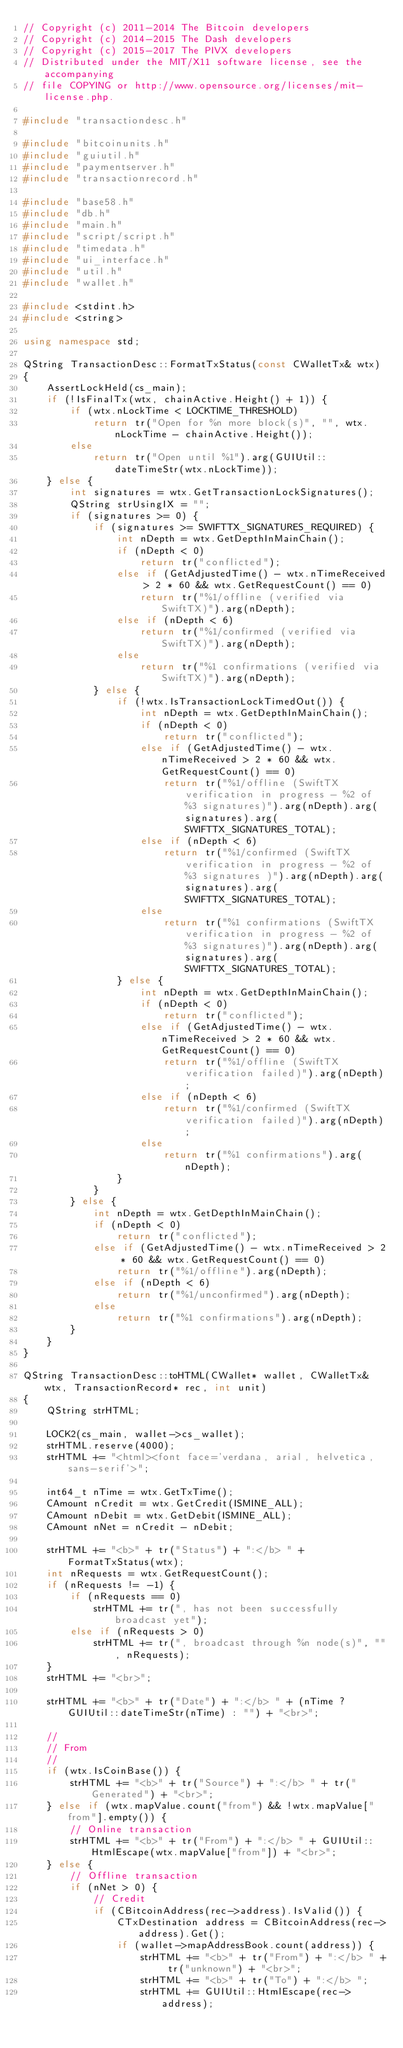Convert code to text. <code><loc_0><loc_0><loc_500><loc_500><_C++_>// Copyright (c) 2011-2014 The Bitcoin developers
// Copyright (c) 2014-2015 The Dash developers
// Copyright (c) 2015-2017 The PIVX developers
// Distributed under the MIT/X11 software license, see the accompanying
// file COPYING or http://www.opensource.org/licenses/mit-license.php.

#include "transactiondesc.h"

#include "bitcoinunits.h"
#include "guiutil.h"
#include "paymentserver.h"
#include "transactionrecord.h"

#include "base58.h"
#include "db.h"
#include "main.h"
#include "script/script.h"
#include "timedata.h"
#include "ui_interface.h"
#include "util.h"
#include "wallet.h"

#include <stdint.h>
#include <string>

using namespace std;

QString TransactionDesc::FormatTxStatus(const CWalletTx& wtx)
{
    AssertLockHeld(cs_main);
    if (!IsFinalTx(wtx, chainActive.Height() + 1)) {
        if (wtx.nLockTime < LOCKTIME_THRESHOLD)
            return tr("Open for %n more block(s)", "", wtx.nLockTime - chainActive.Height());
        else
            return tr("Open until %1").arg(GUIUtil::dateTimeStr(wtx.nLockTime));
    } else {
        int signatures = wtx.GetTransactionLockSignatures();
        QString strUsingIX = "";
        if (signatures >= 0) {
            if (signatures >= SWIFTTX_SIGNATURES_REQUIRED) {
                int nDepth = wtx.GetDepthInMainChain();
                if (nDepth < 0)
                    return tr("conflicted");
                else if (GetAdjustedTime() - wtx.nTimeReceived > 2 * 60 && wtx.GetRequestCount() == 0)
                    return tr("%1/offline (verified via SwiftTX)").arg(nDepth);
                else if (nDepth < 6)
                    return tr("%1/confirmed (verified via SwiftTX)").arg(nDepth);
                else
                    return tr("%1 confirmations (verified via SwiftTX)").arg(nDepth);
            } else {
                if (!wtx.IsTransactionLockTimedOut()) {
                    int nDepth = wtx.GetDepthInMainChain();
                    if (nDepth < 0)
                        return tr("conflicted");
                    else if (GetAdjustedTime() - wtx.nTimeReceived > 2 * 60 && wtx.GetRequestCount() == 0)
                        return tr("%1/offline (SwiftTX verification in progress - %2 of %3 signatures)").arg(nDepth).arg(signatures).arg(SWIFTTX_SIGNATURES_TOTAL);
                    else if (nDepth < 6)
                        return tr("%1/confirmed (SwiftTX verification in progress - %2 of %3 signatures )").arg(nDepth).arg(signatures).arg(SWIFTTX_SIGNATURES_TOTAL);
                    else
                        return tr("%1 confirmations (SwiftTX verification in progress - %2 of %3 signatures)").arg(nDepth).arg(signatures).arg(SWIFTTX_SIGNATURES_TOTAL);
                } else {
                    int nDepth = wtx.GetDepthInMainChain();
                    if (nDepth < 0)
                        return tr("conflicted");
                    else if (GetAdjustedTime() - wtx.nTimeReceived > 2 * 60 && wtx.GetRequestCount() == 0)
                        return tr("%1/offline (SwiftTX verification failed)").arg(nDepth);
                    else if (nDepth < 6)
                        return tr("%1/confirmed (SwiftTX verification failed)").arg(nDepth);
                    else
                        return tr("%1 confirmations").arg(nDepth);
                }
            }
        } else {
            int nDepth = wtx.GetDepthInMainChain();
            if (nDepth < 0)
                return tr("conflicted");
            else if (GetAdjustedTime() - wtx.nTimeReceived > 2 * 60 && wtx.GetRequestCount() == 0)
                return tr("%1/offline").arg(nDepth);
            else if (nDepth < 6)
                return tr("%1/unconfirmed").arg(nDepth);
            else
                return tr("%1 confirmations").arg(nDepth);
        }
    }
}

QString TransactionDesc::toHTML(CWallet* wallet, CWalletTx& wtx, TransactionRecord* rec, int unit)
{
    QString strHTML;

    LOCK2(cs_main, wallet->cs_wallet);
    strHTML.reserve(4000);
    strHTML += "<html><font face='verdana, arial, helvetica, sans-serif'>";

    int64_t nTime = wtx.GetTxTime();
    CAmount nCredit = wtx.GetCredit(ISMINE_ALL);
    CAmount nDebit = wtx.GetDebit(ISMINE_ALL);
    CAmount nNet = nCredit - nDebit;

    strHTML += "<b>" + tr("Status") + ":</b> " + FormatTxStatus(wtx);
    int nRequests = wtx.GetRequestCount();
    if (nRequests != -1) {
        if (nRequests == 0)
            strHTML += tr(", has not been successfully broadcast yet");
        else if (nRequests > 0)
            strHTML += tr(", broadcast through %n node(s)", "", nRequests);
    }
    strHTML += "<br>";

    strHTML += "<b>" + tr("Date") + ":</b> " + (nTime ? GUIUtil::dateTimeStr(nTime) : "") + "<br>";

    //
    // From
    //
    if (wtx.IsCoinBase()) {
        strHTML += "<b>" + tr("Source") + ":</b> " + tr("Generated") + "<br>";
    } else if (wtx.mapValue.count("from") && !wtx.mapValue["from"].empty()) {
        // Online transaction
        strHTML += "<b>" + tr("From") + ":</b> " + GUIUtil::HtmlEscape(wtx.mapValue["from"]) + "<br>";
    } else {
        // Offline transaction
        if (nNet > 0) {
            // Credit
            if (CBitcoinAddress(rec->address).IsValid()) {
                CTxDestination address = CBitcoinAddress(rec->address).Get();
                if (wallet->mapAddressBook.count(address)) {
                    strHTML += "<b>" + tr("From") + ":</b> " + tr("unknown") + "<br>";
                    strHTML += "<b>" + tr("To") + ":</b> ";
                    strHTML += GUIUtil::HtmlEscape(rec->address);</code> 